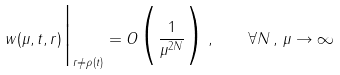<formula> <loc_0><loc_0><loc_500><loc_500>w ( \mu , t , r ) \Big | _ { r \ne \rho ( t ) } = O \Big ( \frac { 1 } { \mu ^ { 2 N } } \Big ) \, , \quad \forall N \, , \, \mu \to \infty</formula> 